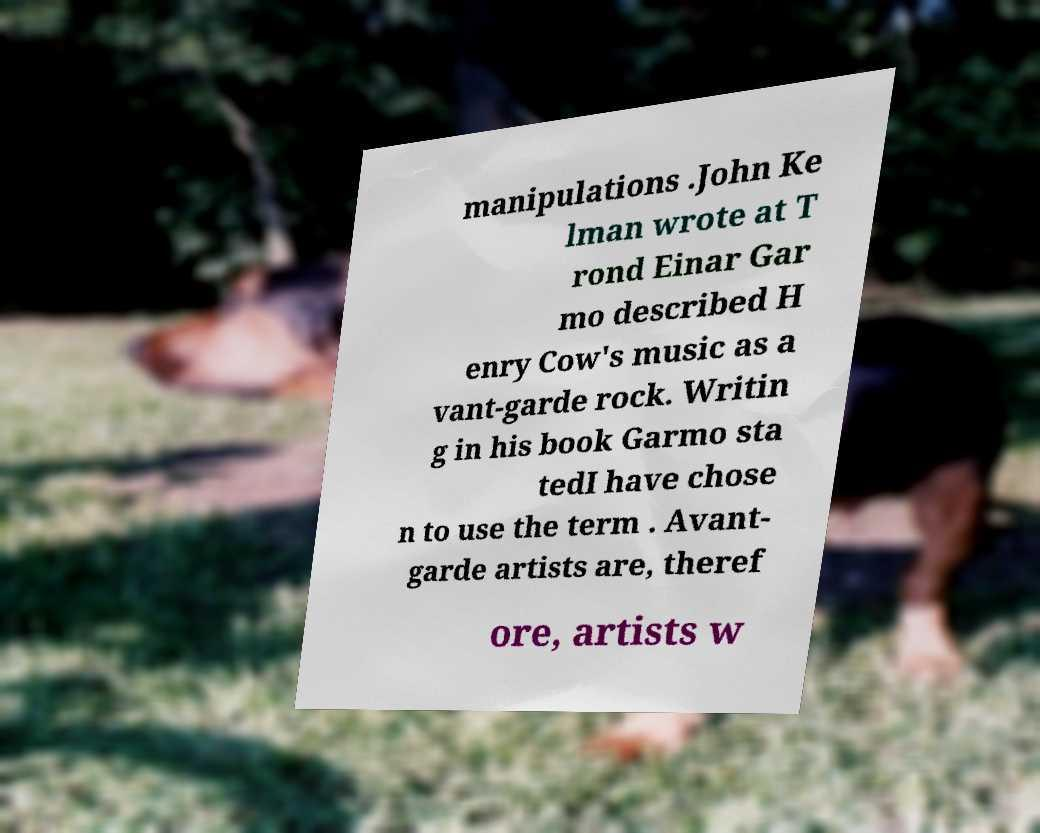Can you accurately transcribe the text from the provided image for me? manipulations .John Ke lman wrote at T rond Einar Gar mo described H enry Cow's music as a vant-garde rock. Writin g in his book Garmo sta tedI have chose n to use the term . Avant- garde artists are, theref ore, artists w 